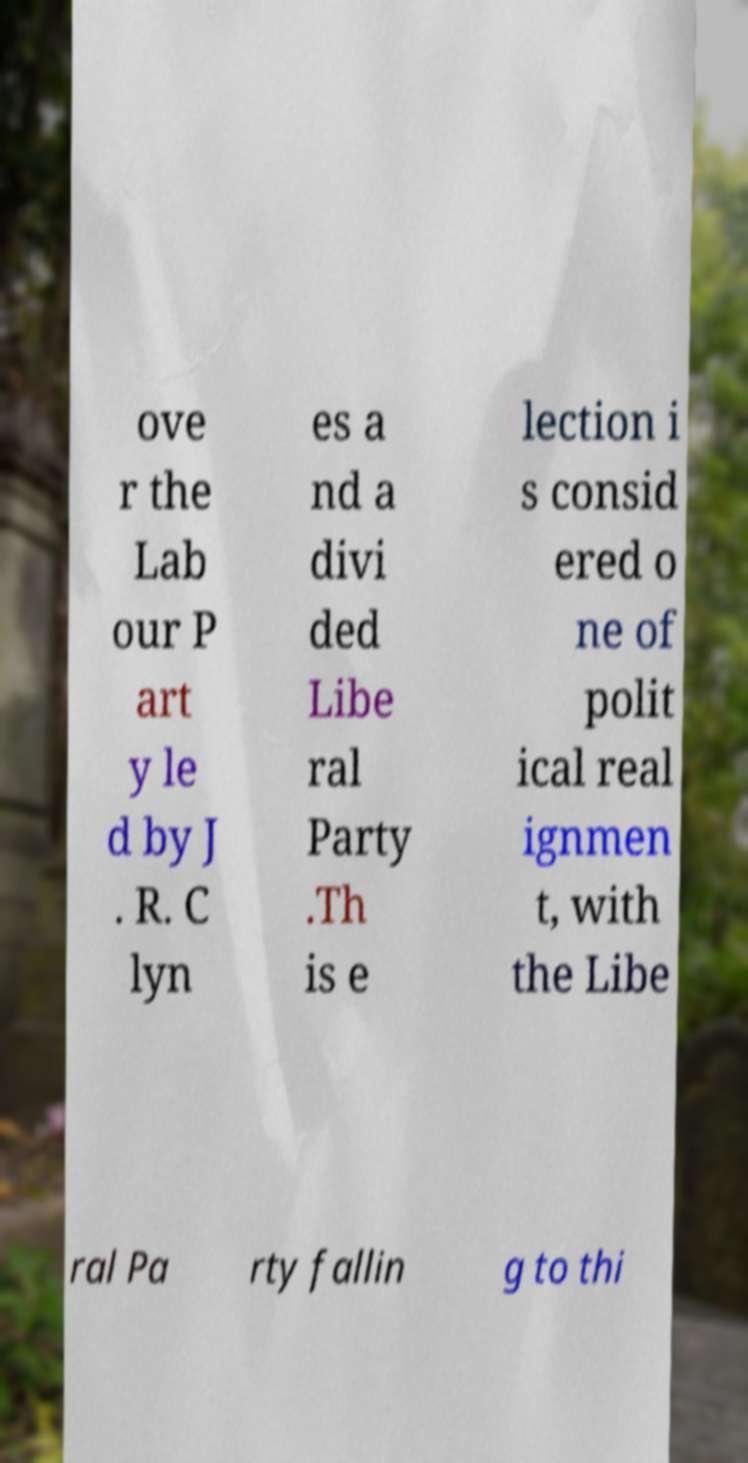Please identify and transcribe the text found in this image. ove r the Lab our P art y le d by J . R. C lyn es a nd a divi ded Libe ral Party .Th is e lection i s consid ered o ne of polit ical real ignmen t, with the Libe ral Pa rty fallin g to thi 